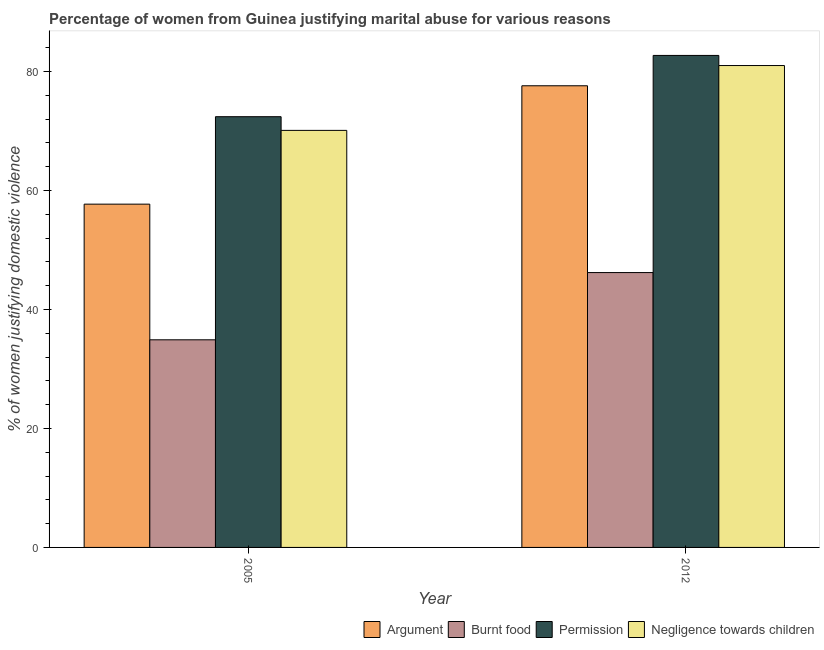Are the number of bars per tick equal to the number of legend labels?
Give a very brief answer. Yes. What is the label of the 2nd group of bars from the left?
Provide a succinct answer. 2012. What is the percentage of women justifying abuse for burning food in 2012?
Your answer should be very brief. 46.2. Across all years, what is the maximum percentage of women justifying abuse for showing negligence towards children?
Offer a terse response. 81. Across all years, what is the minimum percentage of women justifying abuse in the case of an argument?
Offer a terse response. 57.7. In which year was the percentage of women justifying abuse for showing negligence towards children minimum?
Make the answer very short. 2005. What is the total percentage of women justifying abuse for showing negligence towards children in the graph?
Ensure brevity in your answer.  151.1. What is the difference between the percentage of women justifying abuse for showing negligence towards children in 2005 and that in 2012?
Your answer should be compact. -10.9. What is the difference between the percentage of women justifying abuse for burning food in 2005 and the percentage of women justifying abuse for going without permission in 2012?
Your response must be concise. -11.3. What is the average percentage of women justifying abuse for showing negligence towards children per year?
Your response must be concise. 75.55. What is the ratio of the percentage of women justifying abuse in the case of an argument in 2005 to that in 2012?
Give a very brief answer. 0.74. Is the percentage of women justifying abuse for going without permission in 2005 less than that in 2012?
Give a very brief answer. Yes. In how many years, is the percentage of women justifying abuse for showing negligence towards children greater than the average percentage of women justifying abuse for showing negligence towards children taken over all years?
Offer a very short reply. 1. Is it the case that in every year, the sum of the percentage of women justifying abuse for burning food and percentage of women justifying abuse in the case of an argument is greater than the sum of percentage of women justifying abuse for showing negligence towards children and percentage of women justifying abuse for going without permission?
Provide a succinct answer. Yes. What does the 1st bar from the left in 2005 represents?
Provide a succinct answer. Argument. What does the 3rd bar from the right in 2012 represents?
Ensure brevity in your answer.  Burnt food. Is it the case that in every year, the sum of the percentage of women justifying abuse in the case of an argument and percentage of women justifying abuse for burning food is greater than the percentage of women justifying abuse for going without permission?
Offer a very short reply. Yes. Are all the bars in the graph horizontal?
Make the answer very short. No. What is the difference between two consecutive major ticks on the Y-axis?
Provide a short and direct response. 20. Are the values on the major ticks of Y-axis written in scientific E-notation?
Make the answer very short. No. Does the graph contain any zero values?
Ensure brevity in your answer.  No. Where does the legend appear in the graph?
Your response must be concise. Bottom right. How many legend labels are there?
Offer a very short reply. 4. How are the legend labels stacked?
Your answer should be very brief. Horizontal. What is the title of the graph?
Provide a short and direct response. Percentage of women from Guinea justifying marital abuse for various reasons. Does "Primary schools" appear as one of the legend labels in the graph?
Give a very brief answer. No. What is the label or title of the X-axis?
Your response must be concise. Year. What is the label or title of the Y-axis?
Provide a short and direct response. % of women justifying domestic violence. What is the % of women justifying domestic violence of Argument in 2005?
Provide a succinct answer. 57.7. What is the % of women justifying domestic violence in Burnt food in 2005?
Ensure brevity in your answer.  34.9. What is the % of women justifying domestic violence in Permission in 2005?
Ensure brevity in your answer.  72.4. What is the % of women justifying domestic violence of Negligence towards children in 2005?
Provide a succinct answer. 70.1. What is the % of women justifying domestic violence of Argument in 2012?
Ensure brevity in your answer.  77.6. What is the % of women justifying domestic violence in Burnt food in 2012?
Provide a succinct answer. 46.2. What is the % of women justifying domestic violence of Permission in 2012?
Provide a short and direct response. 82.7. What is the % of women justifying domestic violence of Negligence towards children in 2012?
Make the answer very short. 81. Across all years, what is the maximum % of women justifying domestic violence in Argument?
Your response must be concise. 77.6. Across all years, what is the maximum % of women justifying domestic violence of Burnt food?
Ensure brevity in your answer.  46.2. Across all years, what is the maximum % of women justifying domestic violence in Permission?
Your answer should be very brief. 82.7. Across all years, what is the minimum % of women justifying domestic violence in Argument?
Make the answer very short. 57.7. Across all years, what is the minimum % of women justifying domestic violence in Burnt food?
Your answer should be compact. 34.9. Across all years, what is the minimum % of women justifying domestic violence in Permission?
Your answer should be very brief. 72.4. Across all years, what is the minimum % of women justifying domestic violence in Negligence towards children?
Make the answer very short. 70.1. What is the total % of women justifying domestic violence in Argument in the graph?
Your response must be concise. 135.3. What is the total % of women justifying domestic violence of Burnt food in the graph?
Offer a terse response. 81.1. What is the total % of women justifying domestic violence of Permission in the graph?
Your answer should be compact. 155.1. What is the total % of women justifying domestic violence in Negligence towards children in the graph?
Your response must be concise. 151.1. What is the difference between the % of women justifying domestic violence of Argument in 2005 and that in 2012?
Ensure brevity in your answer.  -19.9. What is the difference between the % of women justifying domestic violence of Permission in 2005 and that in 2012?
Provide a succinct answer. -10.3. What is the difference between the % of women justifying domestic violence in Argument in 2005 and the % of women justifying domestic violence in Negligence towards children in 2012?
Make the answer very short. -23.3. What is the difference between the % of women justifying domestic violence in Burnt food in 2005 and the % of women justifying domestic violence in Permission in 2012?
Your answer should be very brief. -47.8. What is the difference between the % of women justifying domestic violence in Burnt food in 2005 and the % of women justifying domestic violence in Negligence towards children in 2012?
Your answer should be compact. -46.1. What is the average % of women justifying domestic violence in Argument per year?
Your response must be concise. 67.65. What is the average % of women justifying domestic violence in Burnt food per year?
Your response must be concise. 40.55. What is the average % of women justifying domestic violence of Permission per year?
Your answer should be compact. 77.55. What is the average % of women justifying domestic violence in Negligence towards children per year?
Keep it short and to the point. 75.55. In the year 2005, what is the difference between the % of women justifying domestic violence of Argument and % of women justifying domestic violence of Burnt food?
Ensure brevity in your answer.  22.8. In the year 2005, what is the difference between the % of women justifying domestic violence of Argument and % of women justifying domestic violence of Permission?
Your response must be concise. -14.7. In the year 2005, what is the difference between the % of women justifying domestic violence in Argument and % of women justifying domestic violence in Negligence towards children?
Keep it short and to the point. -12.4. In the year 2005, what is the difference between the % of women justifying domestic violence of Burnt food and % of women justifying domestic violence of Permission?
Ensure brevity in your answer.  -37.5. In the year 2005, what is the difference between the % of women justifying domestic violence in Burnt food and % of women justifying domestic violence in Negligence towards children?
Make the answer very short. -35.2. In the year 2005, what is the difference between the % of women justifying domestic violence of Permission and % of women justifying domestic violence of Negligence towards children?
Ensure brevity in your answer.  2.3. In the year 2012, what is the difference between the % of women justifying domestic violence in Argument and % of women justifying domestic violence in Burnt food?
Offer a terse response. 31.4. In the year 2012, what is the difference between the % of women justifying domestic violence of Argument and % of women justifying domestic violence of Permission?
Your answer should be very brief. -5.1. In the year 2012, what is the difference between the % of women justifying domestic violence in Burnt food and % of women justifying domestic violence in Permission?
Your answer should be compact. -36.5. In the year 2012, what is the difference between the % of women justifying domestic violence in Burnt food and % of women justifying domestic violence in Negligence towards children?
Provide a short and direct response. -34.8. What is the ratio of the % of women justifying domestic violence of Argument in 2005 to that in 2012?
Provide a short and direct response. 0.74. What is the ratio of the % of women justifying domestic violence of Burnt food in 2005 to that in 2012?
Make the answer very short. 0.76. What is the ratio of the % of women justifying domestic violence in Permission in 2005 to that in 2012?
Provide a short and direct response. 0.88. What is the ratio of the % of women justifying domestic violence in Negligence towards children in 2005 to that in 2012?
Provide a succinct answer. 0.87. What is the difference between the highest and the second highest % of women justifying domestic violence of Burnt food?
Give a very brief answer. 11.3. What is the difference between the highest and the second highest % of women justifying domestic violence of Permission?
Provide a succinct answer. 10.3. What is the difference between the highest and the second highest % of women justifying domestic violence of Negligence towards children?
Your answer should be compact. 10.9. What is the difference between the highest and the lowest % of women justifying domestic violence in Burnt food?
Provide a short and direct response. 11.3. What is the difference between the highest and the lowest % of women justifying domestic violence in Permission?
Offer a very short reply. 10.3. What is the difference between the highest and the lowest % of women justifying domestic violence in Negligence towards children?
Ensure brevity in your answer.  10.9. 